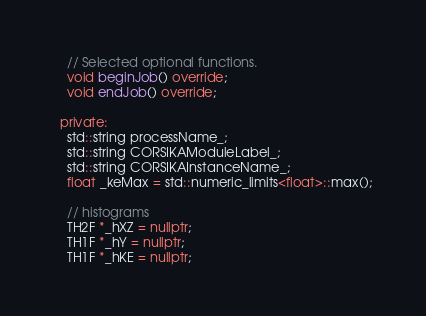Convert code to text. <code><loc_0><loc_0><loc_500><loc_500><_C++_>    // Selected optional functions.
    void beginJob() override;
    void endJob() override;

  private:
    std::string processName_;
    std::string CORSIKAModuleLabel_;
    std::string CORSIKAInstanceName_;
    float _keMax = std::numeric_limits<float>::max();

    // histograms
    TH2F *_hXZ = nullptr;
    TH1F *_hY = nullptr;
    TH1F *_hKE = nullptr;</code> 